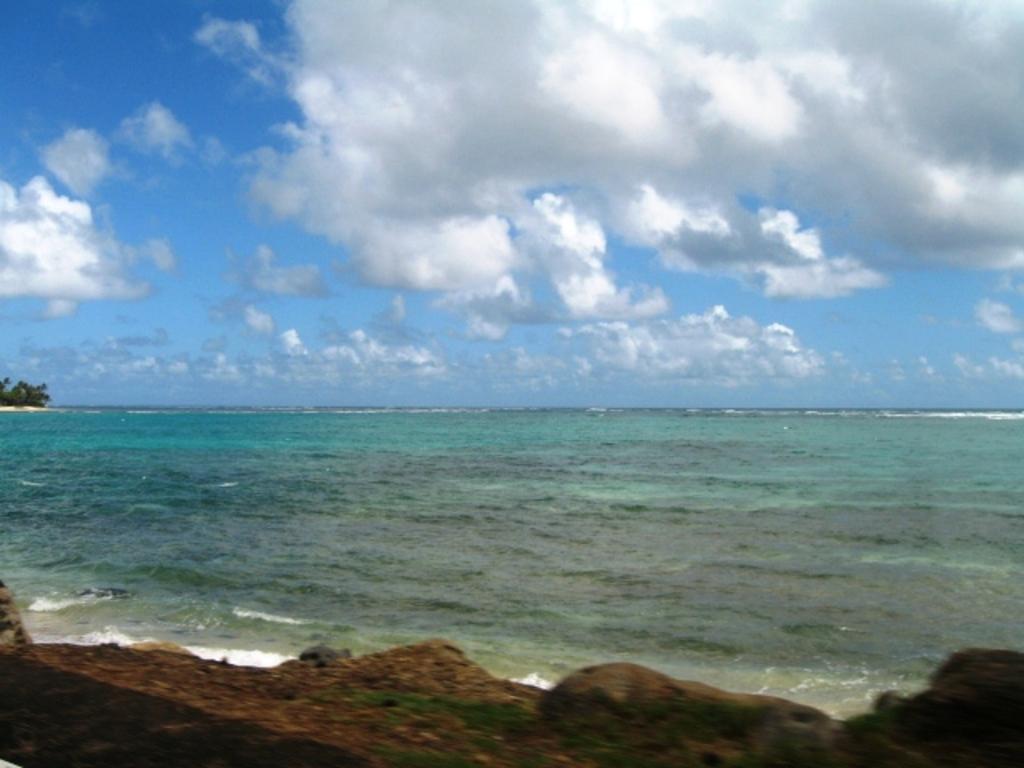Could you give a brief overview of what you see in this image? In this image I can see water, clouds and the sky in background. I can also see few trees over there. 